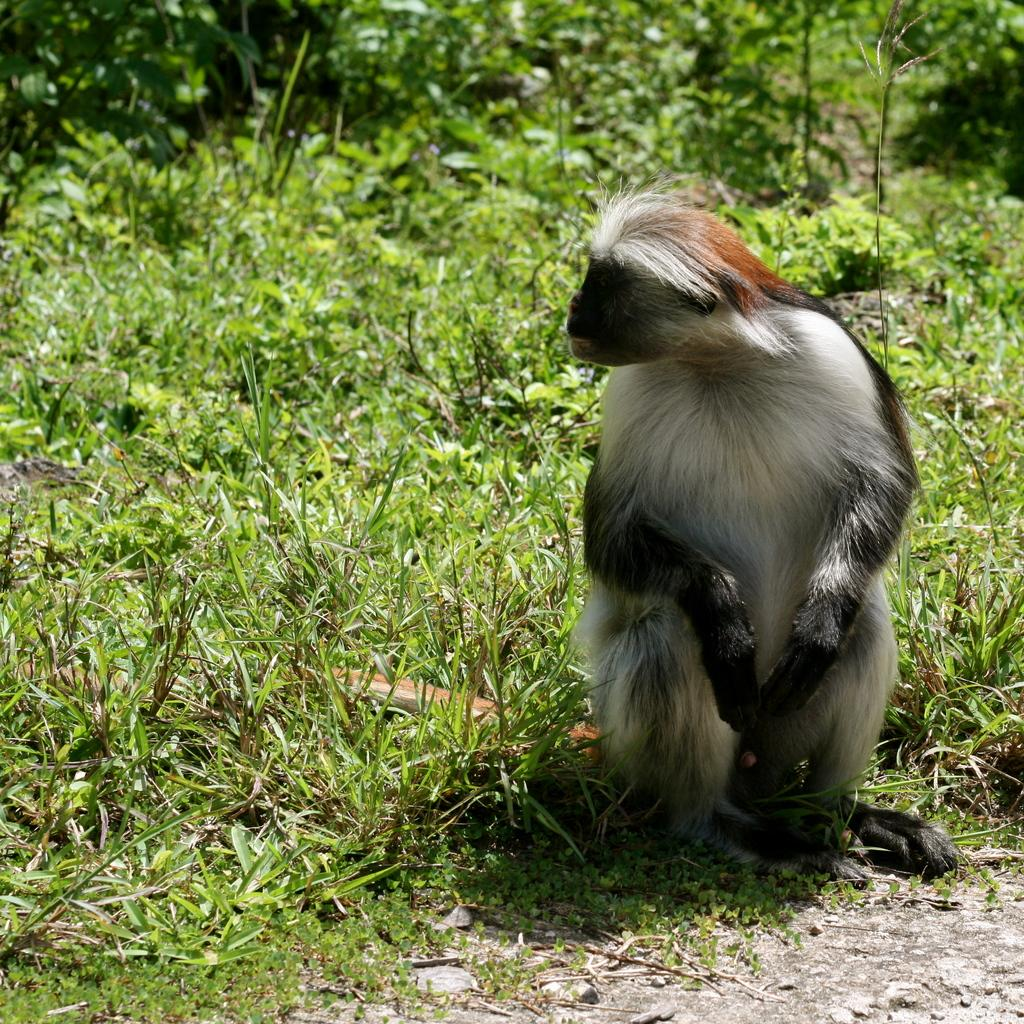What is the main subject in the center of the image? There is an animal in the center of the image. What can be seen in the background of the image? There are trees in the background of the image. What type of vegetation is present on the ground in the image? There is grass on the ground in the image. What type of tail does the grandfather have in the image? There is no grandfather present in the image, and therefore no tail to describe. 